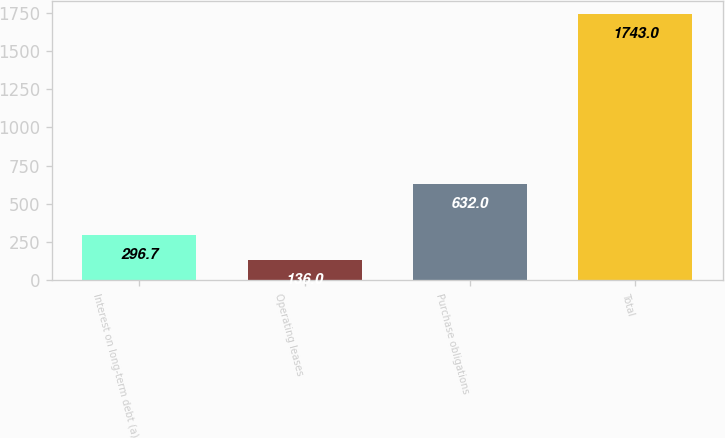Convert chart to OTSL. <chart><loc_0><loc_0><loc_500><loc_500><bar_chart><fcel>Interest on long-term debt (a)<fcel>Operating leases<fcel>Purchase obligations<fcel>Total<nl><fcel>296.7<fcel>136<fcel>632<fcel>1743<nl></chart> 